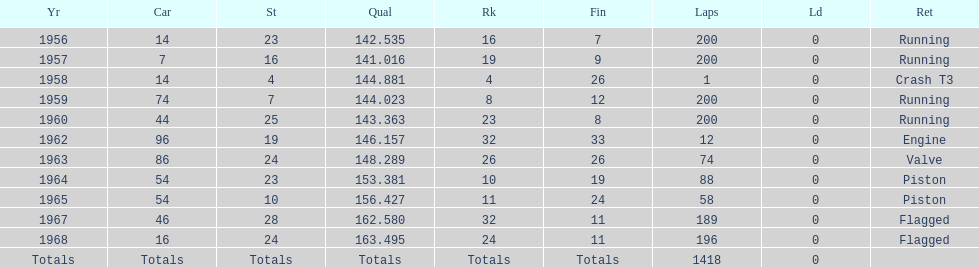What was its best starting position? 4. 